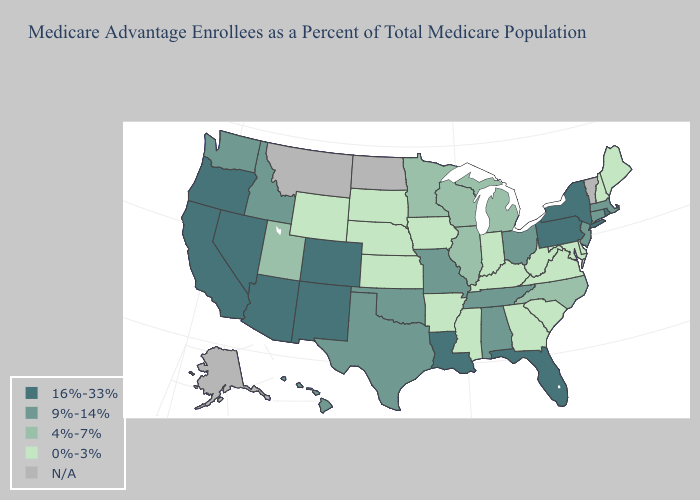What is the value of Oklahoma?
Short answer required. 9%-14%. Does the map have missing data?
Give a very brief answer. Yes. Name the states that have a value in the range 0%-3%?
Write a very short answer. Arkansas, Delaware, Georgia, Iowa, Indiana, Kansas, Kentucky, Maryland, Maine, Mississippi, Nebraska, New Hampshire, South Carolina, South Dakota, Virginia, West Virginia, Wyoming. What is the value of Michigan?
Be succinct. 4%-7%. Does Kansas have the lowest value in the MidWest?
Answer briefly. Yes. Which states hav the highest value in the Northeast?
Keep it brief. New York, Pennsylvania, Rhode Island. What is the value of Alabama?
Write a very short answer. 9%-14%. Name the states that have a value in the range N/A?
Concise answer only. Alaska, Montana, North Dakota, Vermont. Among the states that border Minnesota , does Wisconsin have the lowest value?
Short answer required. No. Among the states that border Louisiana , does Arkansas have the lowest value?
Short answer required. Yes. Among the states that border Virginia , which have the lowest value?
Answer briefly. Kentucky, Maryland, West Virginia. Does Wyoming have the lowest value in the West?
Quick response, please. Yes. Among the states that border Arkansas , does Mississippi have the lowest value?
Short answer required. Yes. 